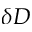Convert formula to latex. <formula><loc_0><loc_0><loc_500><loc_500>\delta D</formula> 